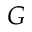Convert formula to latex. <formula><loc_0><loc_0><loc_500><loc_500>G</formula> 